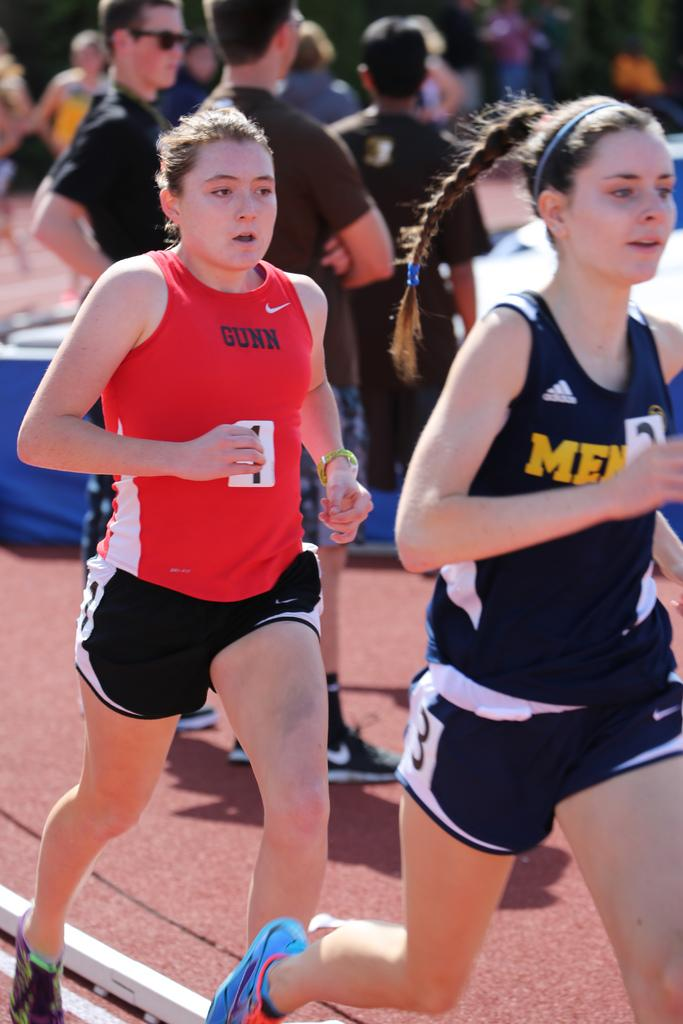What are the women in the image doing? The women in the image are running. Where are the women running? The women are running on a road. Are there any other people visible in the image? Yes, there are persons standing in the background of the image. What type of spade can be seen in the image? There is no spade present in the image. What statement is being made by the women in the image? The image does not provide any information about a statement being made by the women. 